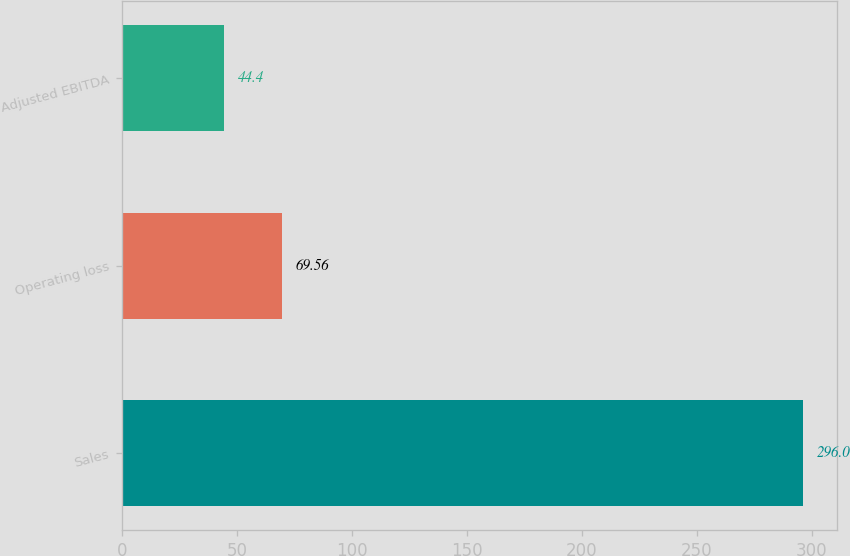<chart> <loc_0><loc_0><loc_500><loc_500><bar_chart><fcel>Sales<fcel>Operating loss<fcel>Adjusted EBITDA<nl><fcel>296<fcel>69.56<fcel>44.4<nl></chart> 